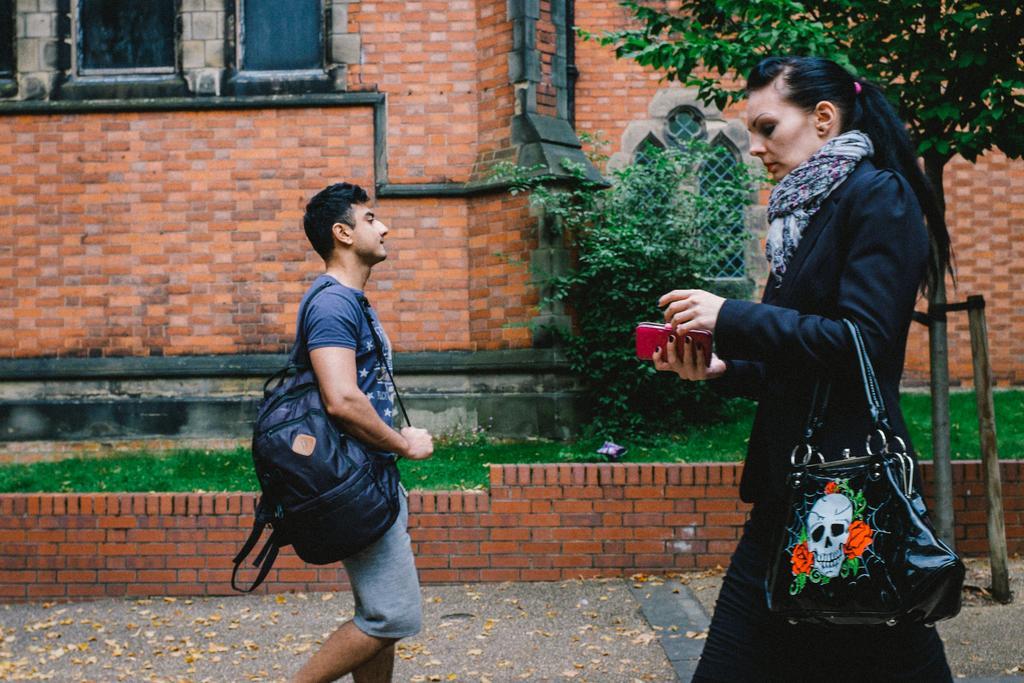In one or two sentences, can you explain what this image depicts? In this image in the front on the right side there is a woman walking and holding an object which is red in colour in her hand and holding a bag which is black in colour. In the center there is a man walking and wearing a bag which is black in colour. In the background there is a building, there is grass on the ground and there are plants and there are dry leaves on the ground. 